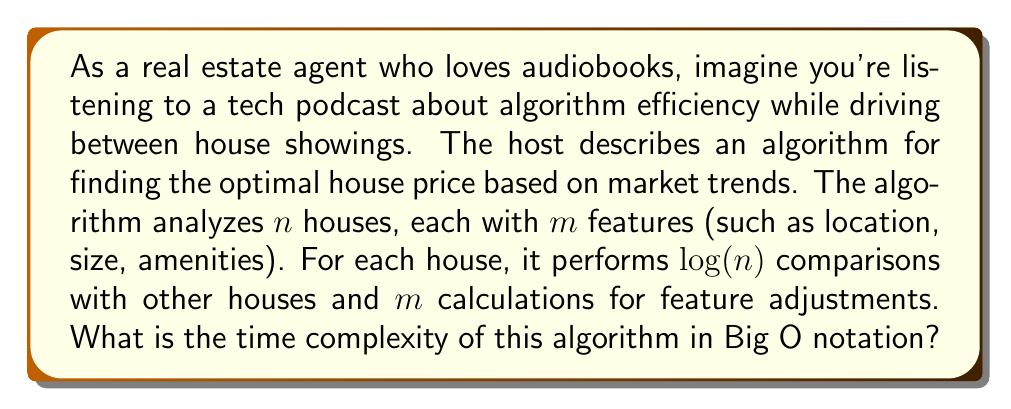Can you answer this question? Let's break down the algorithm's operations:

1. The algorithm analyzes $n$ houses.
2. For each house, it performs $\log(n)$ comparisons.
3. For each house, it also performs $m$ calculations for feature adjustments.

To determine the time complexity:

1. The $\log(n)$ comparisons for each house result in:
   $n \cdot \log(n)$ operations

2. The $m$ calculations for each house result in:
   $n \cdot m$ operations

3. Combining these operations:
   Total operations = $n \cdot \log(n) + n \cdot m$

4. In Big O notation, we focus on the dominant term as $n$ grows large. Here, both terms grow with $n$, so we keep both:
   $O(n \log(n) + nm)$

5. We can factor out $n$:
   $O(n(\log(n) + m))$

This form represents the time complexity of the algorithm.
Answer: $O(n(\log(n) + m))$ 